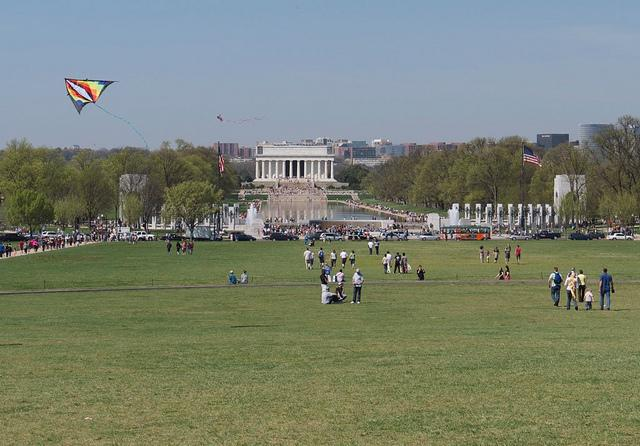In which country is this park located? Please explain your reasoning. united states. This is at a national monument in washington, d.c. 